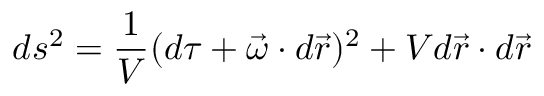<formula> <loc_0><loc_0><loc_500><loc_500>d s ^ { 2 } = \frac { 1 } { V } ( d \tau + \vec { \omega } \cdot d \vec { r } ) ^ { 2 } + V d \vec { r } \cdot d \vec { r }</formula> 